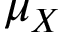<formula> <loc_0><loc_0><loc_500><loc_500>\mu _ { X }</formula> 